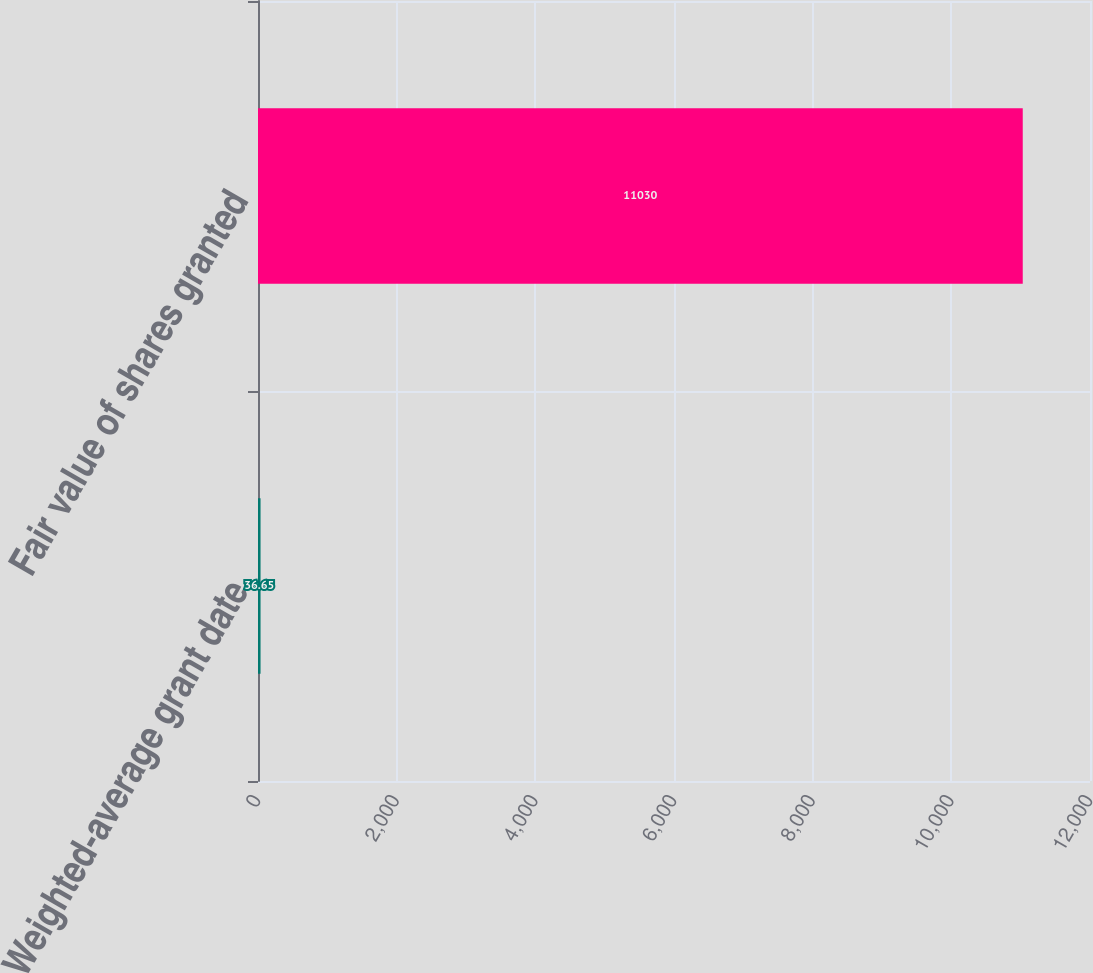Convert chart to OTSL. <chart><loc_0><loc_0><loc_500><loc_500><bar_chart><fcel>Weighted-average grant date<fcel>Fair value of shares granted<nl><fcel>36.65<fcel>11030<nl></chart> 